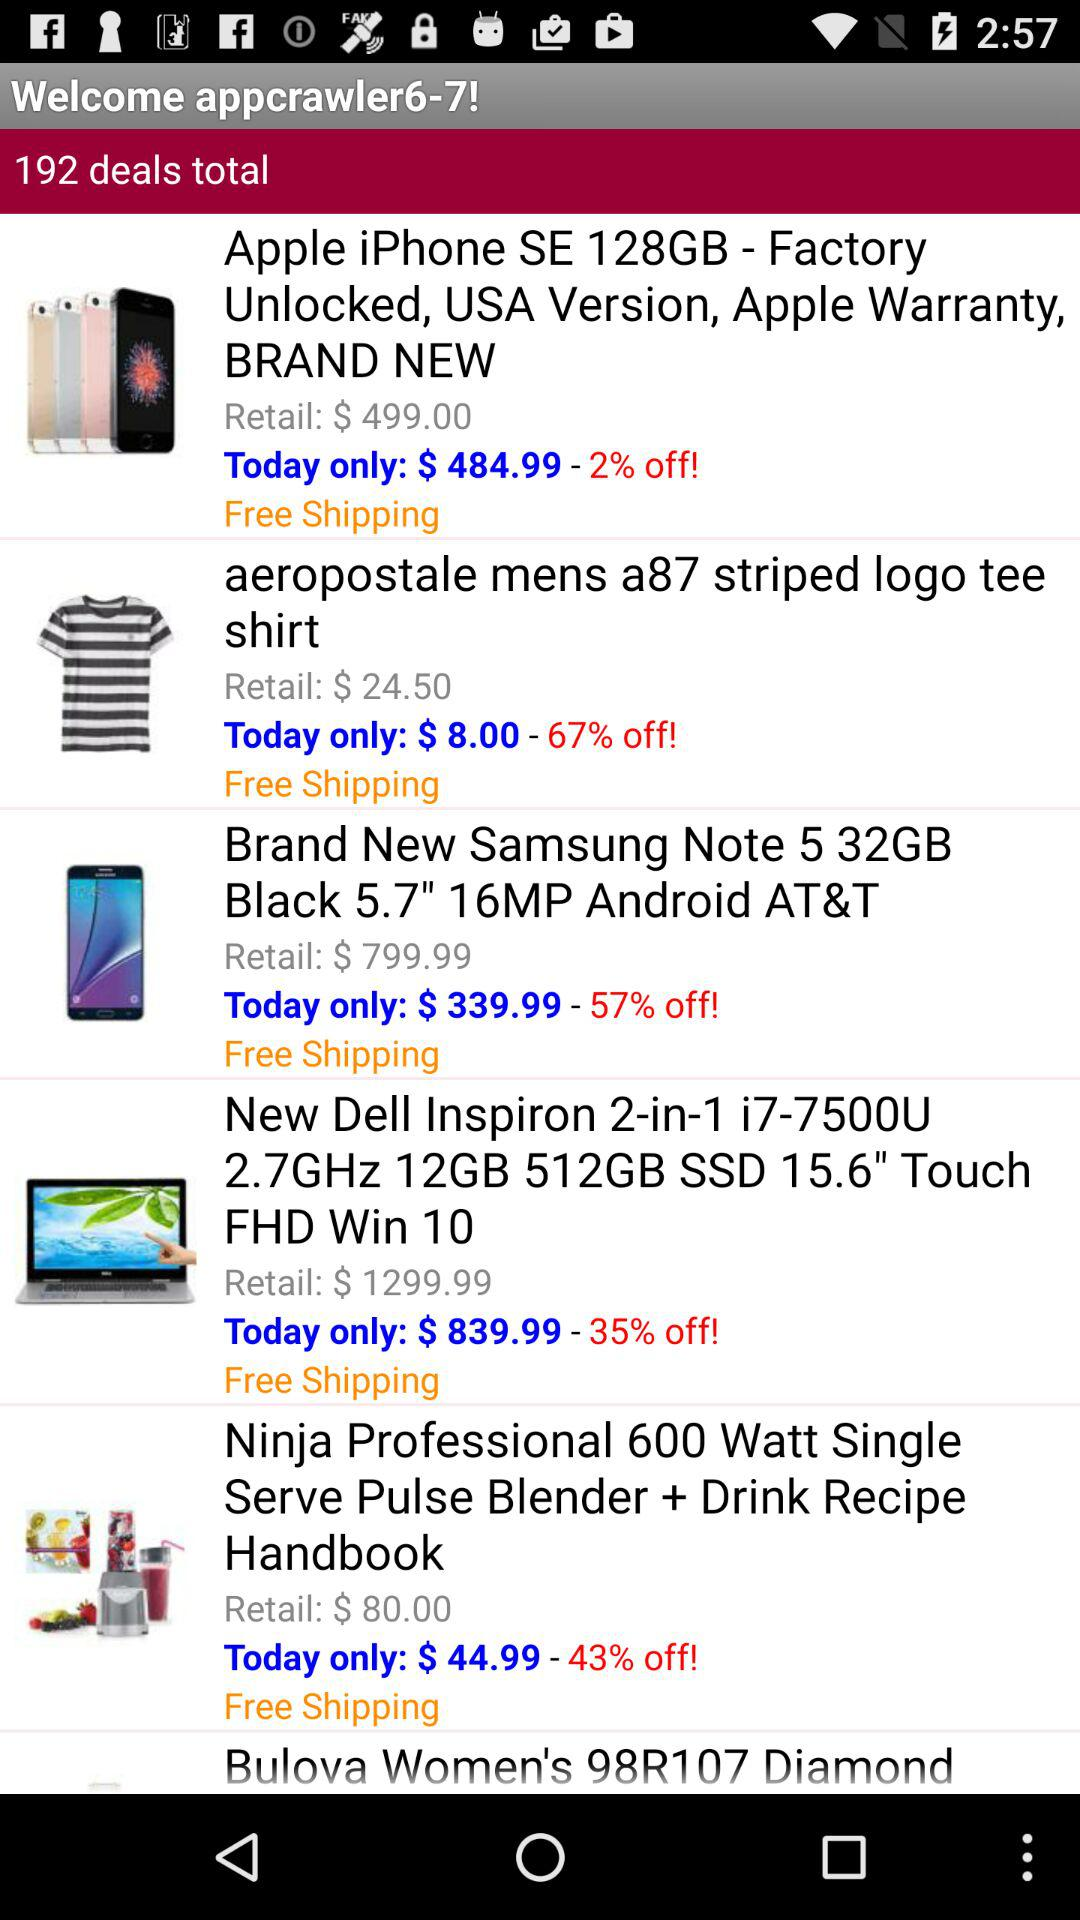How many deals in total are there? There are 192 deals in total. 